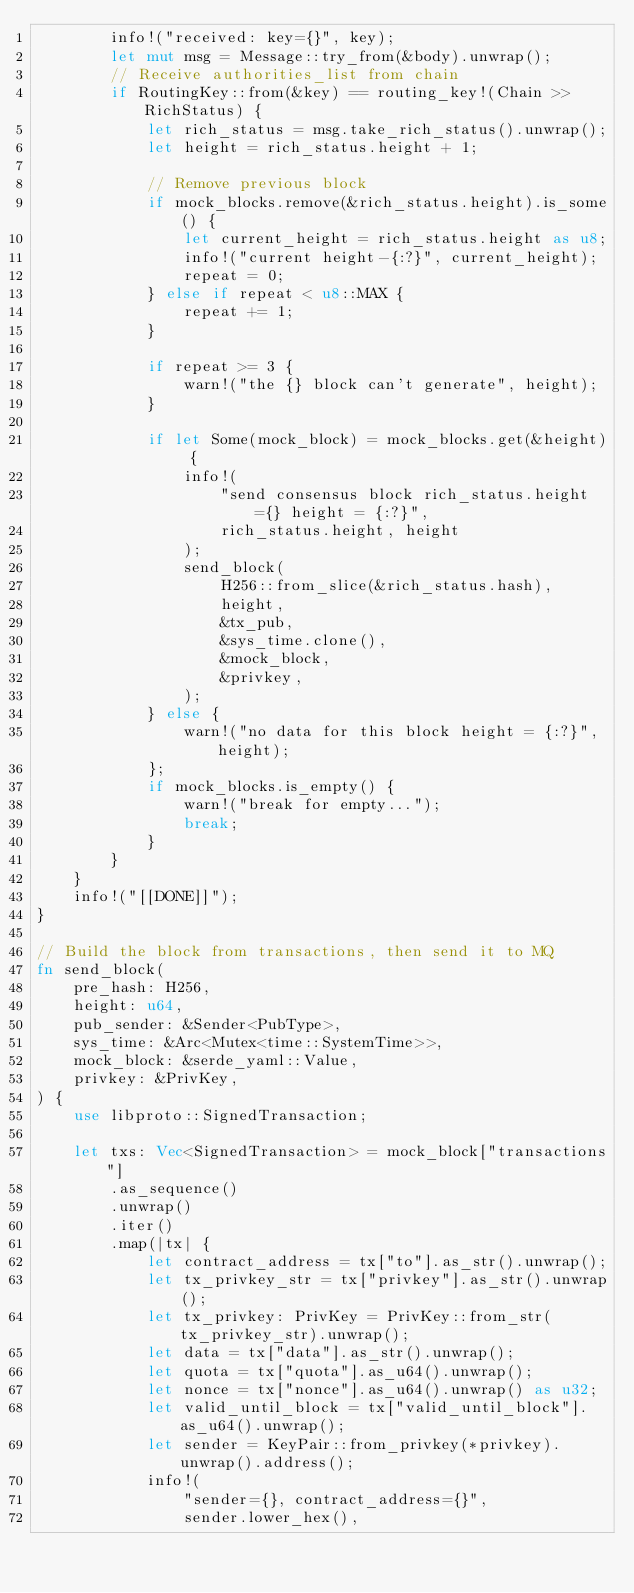Convert code to text. <code><loc_0><loc_0><loc_500><loc_500><_Rust_>        info!("received: key={}", key);
        let mut msg = Message::try_from(&body).unwrap();
        // Receive authorities_list from chain
        if RoutingKey::from(&key) == routing_key!(Chain >> RichStatus) {
            let rich_status = msg.take_rich_status().unwrap();
            let height = rich_status.height + 1;

            // Remove previous block
            if mock_blocks.remove(&rich_status.height).is_some() {
                let current_height = rich_status.height as u8;
                info!("current height-{:?}", current_height);
                repeat = 0;
            } else if repeat < u8::MAX {
                repeat += 1;
            }

            if repeat >= 3 {
                warn!("the {} block can't generate", height);
            }

            if let Some(mock_block) = mock_blocks.get(&height) {
                info!(
                    "send consensus block rich_status.height={} height = {:?}",
                    rich_status.height, height
                );
                send_block(
                    H256::from_slice(&rich_status.hash),
                    height,
                    &tx_pub,
                    &sys_time.clone(),
                    &mock_block,
                    &privkey,
                );
            } else {
                warn!("no data for this block height = {:?}", height);
            };
            if mock_blocks.is_empty() {
                warn!("break for empty...");
                break;
            }
        }
    }
    info!("[[DONE]]");
}

// Build the block from transactions, then send it to MQ
fn send_block(
    pre_hash: H256,
    height: u64,
    pub_sender: &Sender<PubType>,
    sys_time: &Arc<Mutex<time::SystemTime>>,
    mock_block: &serde_yaml::Value,
    privkey: &PrivKey,
) {
    use libproto::SignedTransaction;

    let txs: Vec<SignedTransaction> = mock_block["transactions"]
        .as_sequence()
        .unwrap()
        .iter()
        .map(|tx| {
            let contract_address = tx["to"].as_str().unwrap();
            let tx_privkey_str = tx["privkey"].as_str().unwrap();
            let tx_privkey: PrivKey = PrivKey::from_str(tx_privkey_str).unwrap();
            let data = tx["data"].as_str().unwrap();
            let quota = tx["quota"].as_u64().unwrap();
            let nonce = tx["nonce"].as_u64().unwrap() as u32;
            let valid_until_block = tx["valid_until_block"].as_u64().unwrap();
            let sender = KeyPair::from_privkey(*privkey).unwrap().address();
            info!(
                "sender={}, contract_address={}",
                sender.lower_hex(),</code> 